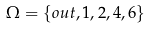<formula> <loc_0><loc_0><loc_500><loc_500>\Omega & = \{ o u t , 1 , 2 , 4 , 6 \}</formula> 